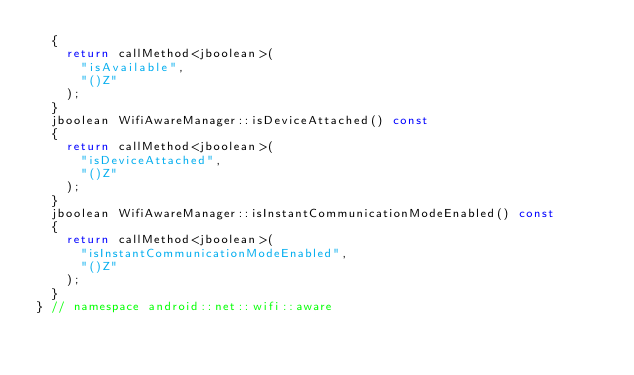Convert code to text. <code><loc_0><loc_0><loc_500><loc_500><_C++_>	{
		return callMethod<jboolean>(
			"isAvailable",
			"()Z"
		);
	}
	jboolean WifiAwareManager::isDeviceAttached() const
	{
		return callMethod<jboolean>(
			"isDeviceAttached",
			"()Z"
		);
	}
	jboolean WifiAwareManager::isInstantCommunicationModeEnabled() const
	{
		return callMethod<jboolean>(
			"isInstantCommunicationModeEnabled",
			"()Z"
		);
	}
} // namespace android::net::wifi::aware

</code> 